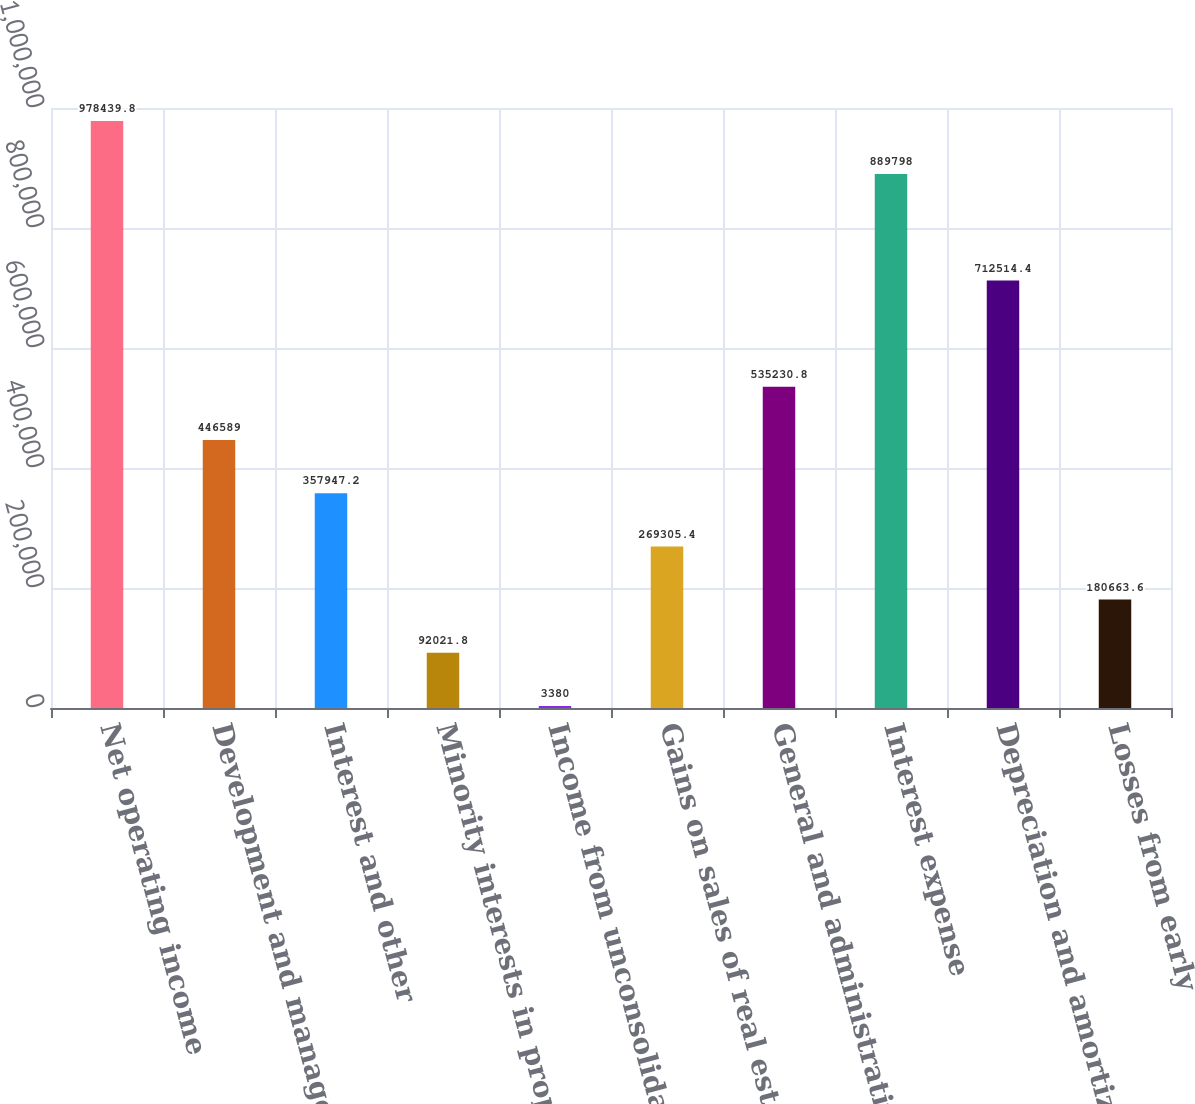Convert chart. <chart><loc_0><loc_0><loc_500><loc_500><bar_chart><fcel>Net operating income<fcel>Development and management<fcel>Interest and other<fcel>Minority interests in property<fcel>Income from unconsolidated<fcel>Gains on sales of real estate<fcel>General and administrative<fcel>Interest expense<fcel>Depreciation and amortization<fcel>Losses from early<nl><fcel>978440<fcel>446589<fcel>357947<fcel>92021.8<fcel>3380<fcel>269305<fcel>535231<fcel>889798<fcel>712514<fcel>180664<nl></chart> 